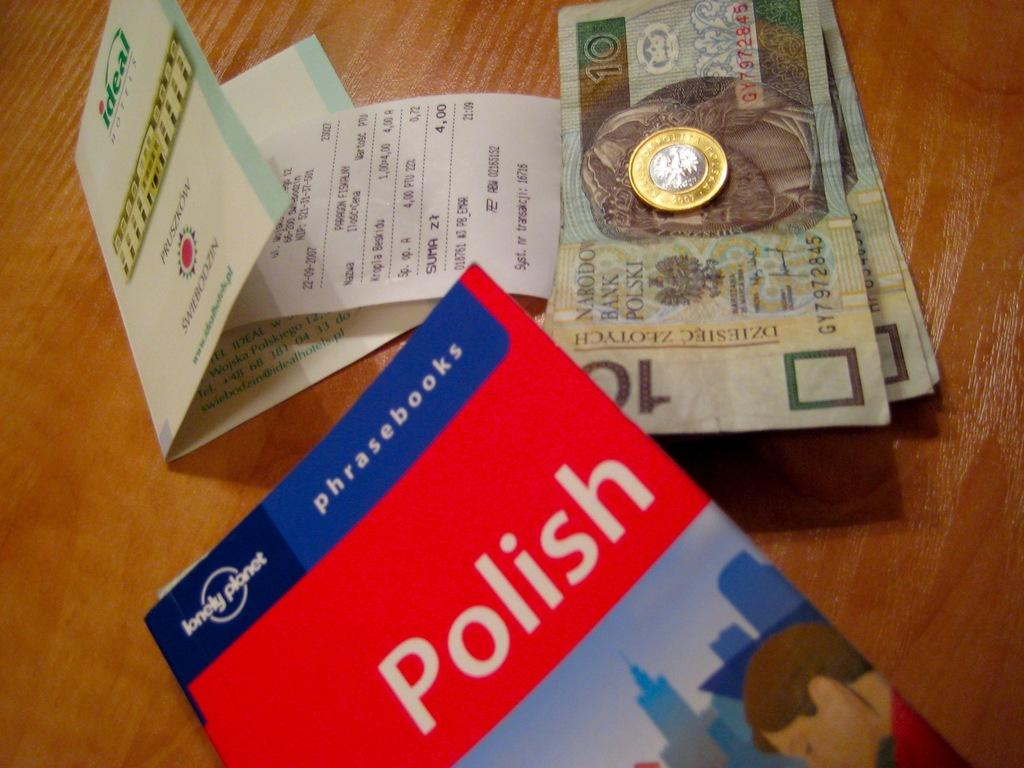<image>
Summarize the visual content of the image. A book about Polish sits on a table with a pile of money and a receipt. 